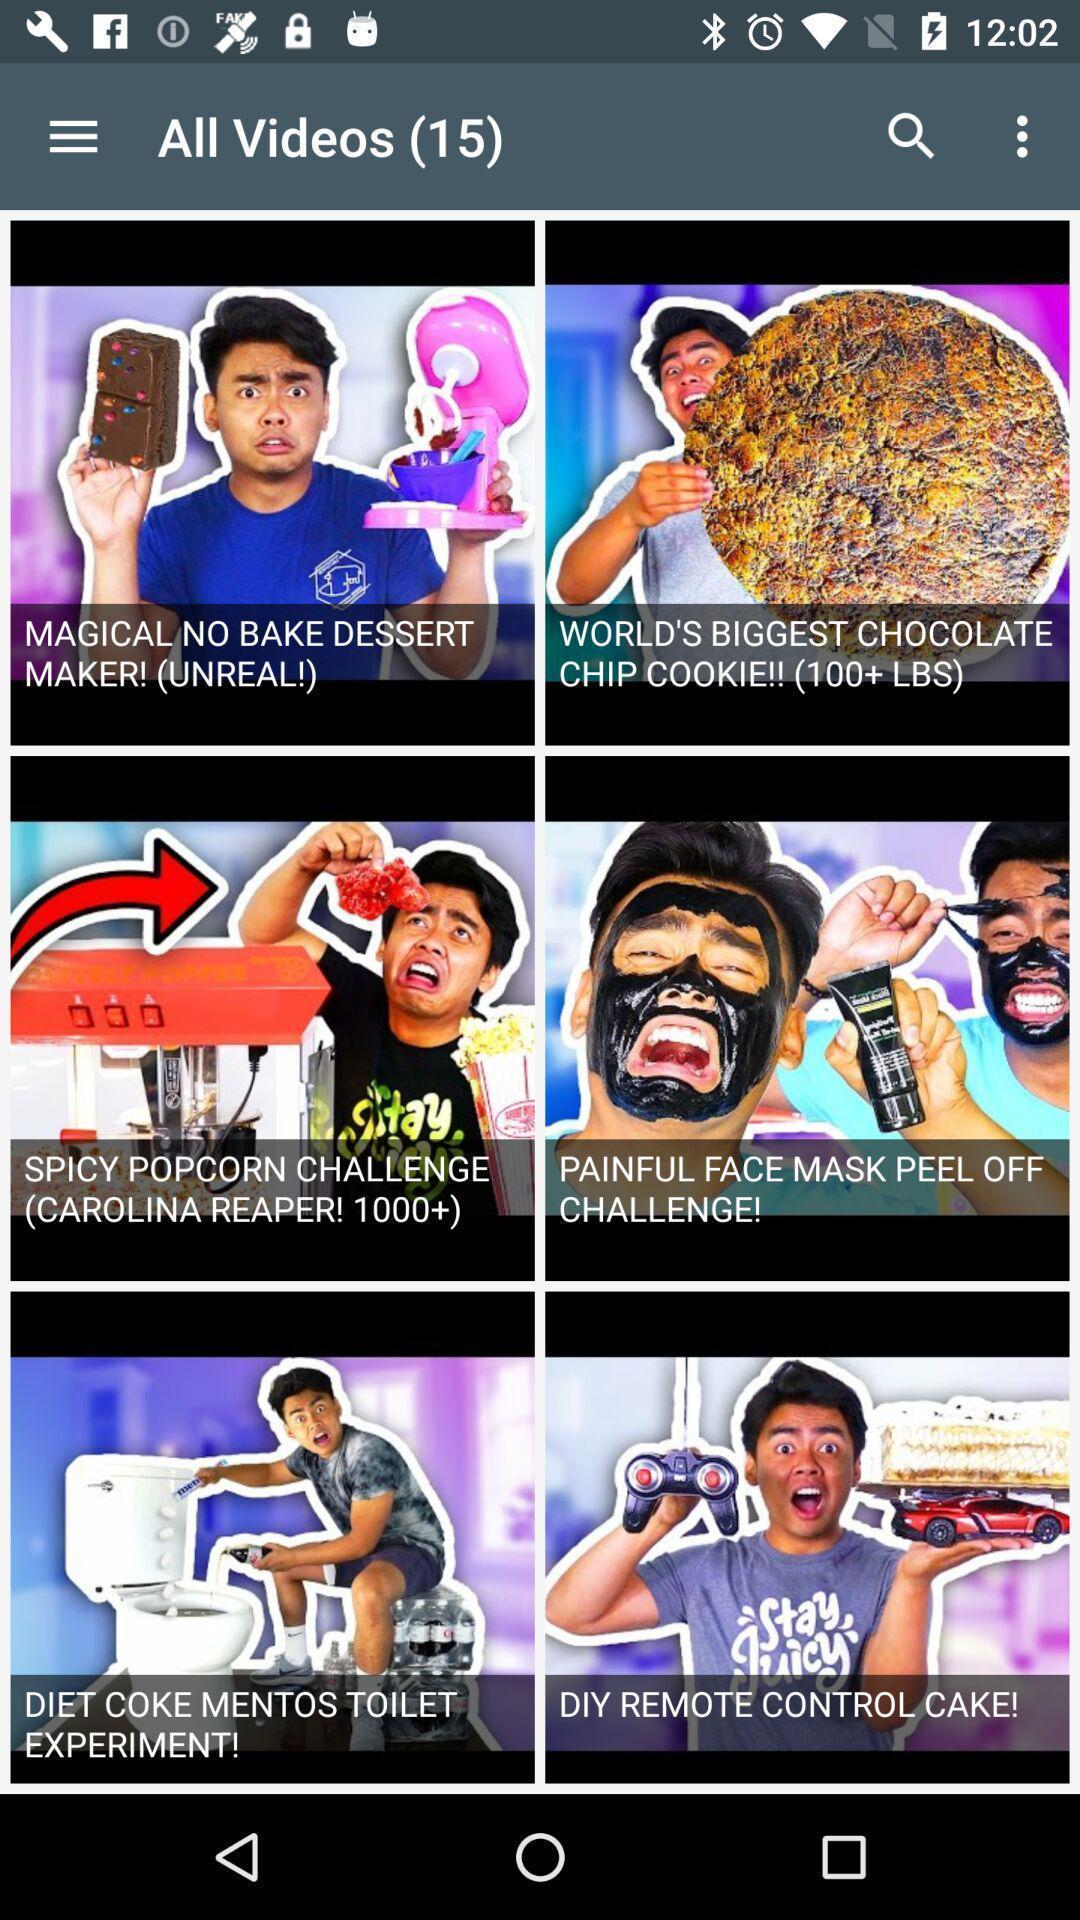Describe this image in words. Page shows few images with some text in entertainment application. 